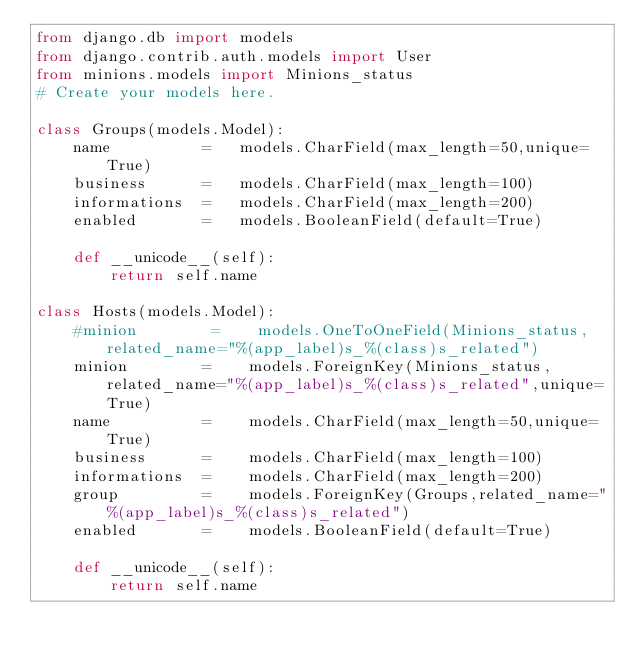Convert code to text. <code><loc_0><loc_0><loc_500><loc_500><_Python_>from django.db import models
from django.contrib.auth.models import User
from minions.models import Minions_status
# Create your models here.

class Groups(models.Model):
    name          =   models.CharField(max_length=50,unique=True)
    business      =   models.CharField(max_length=100)
    informations  =   models.CharField(max_length=200)
    enabled       =   models.BooleanField(default=True)

    def __unicode__(self):
        return self.name

class Hosts(models.Model):
    #minion        =    models.OneToOneField(Minions_status,related_name="%(app_label)s_%(class)s_related")
    minion        =    models.ForeignKey(Minions_status,related_name="%(app_label)s_%(class)s_related",unique=True)
    name          =    models.CharField(max_length=50,unique=True)
    business      =    models.CharField(max_length=100)
    informations  =    models.CharField(max_length=200)
    group         =    models.ForeignKey(Groups,related_name="%(app_label)s_%(class)s_related")
    enabled       =    models.BooleanField(default=True)

    def __unicode__(self):
        return self.name

</code> 